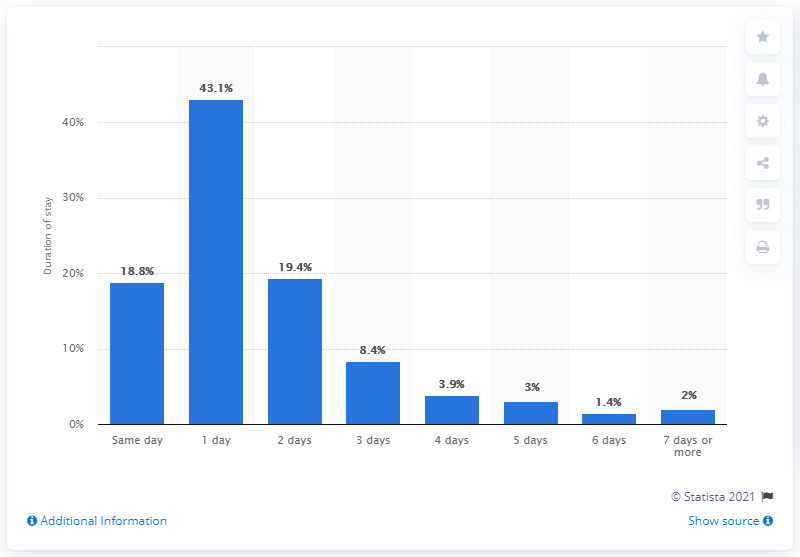Mention a couple of crucial points in this snapshot. In England during the 2019/2020 fiscal year, it was reported that 43.1% of women who gave birth spent at least one day in postnatal care. The median value of all the bars is 6.15. The most prevalent and the least prevalent case of a certain condition have a significant difference in the number of days they have stayed. Specifically, the difference in the number of days is 41.7 days. 